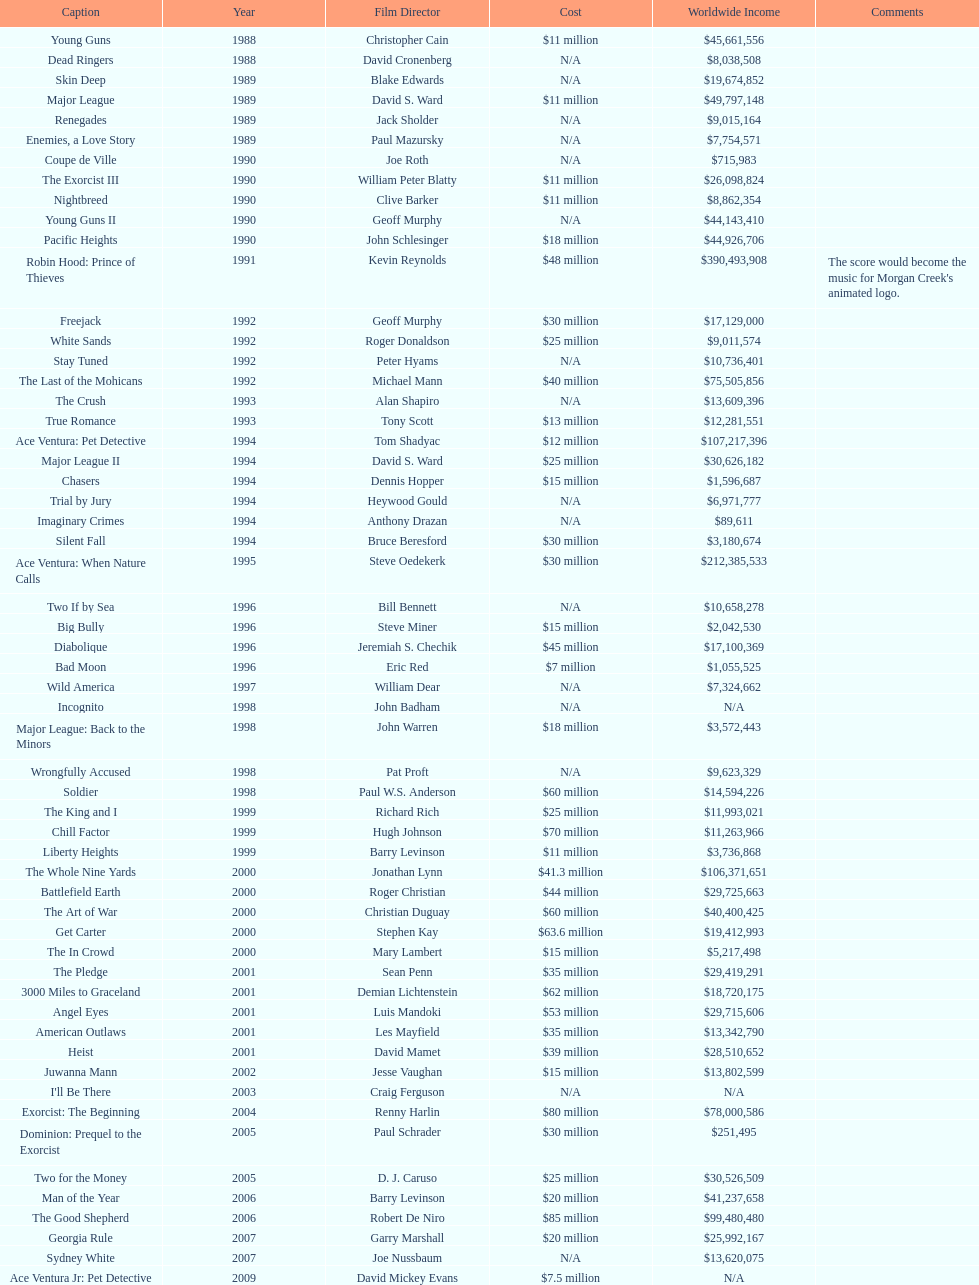How many films were there in 1990? 5. 